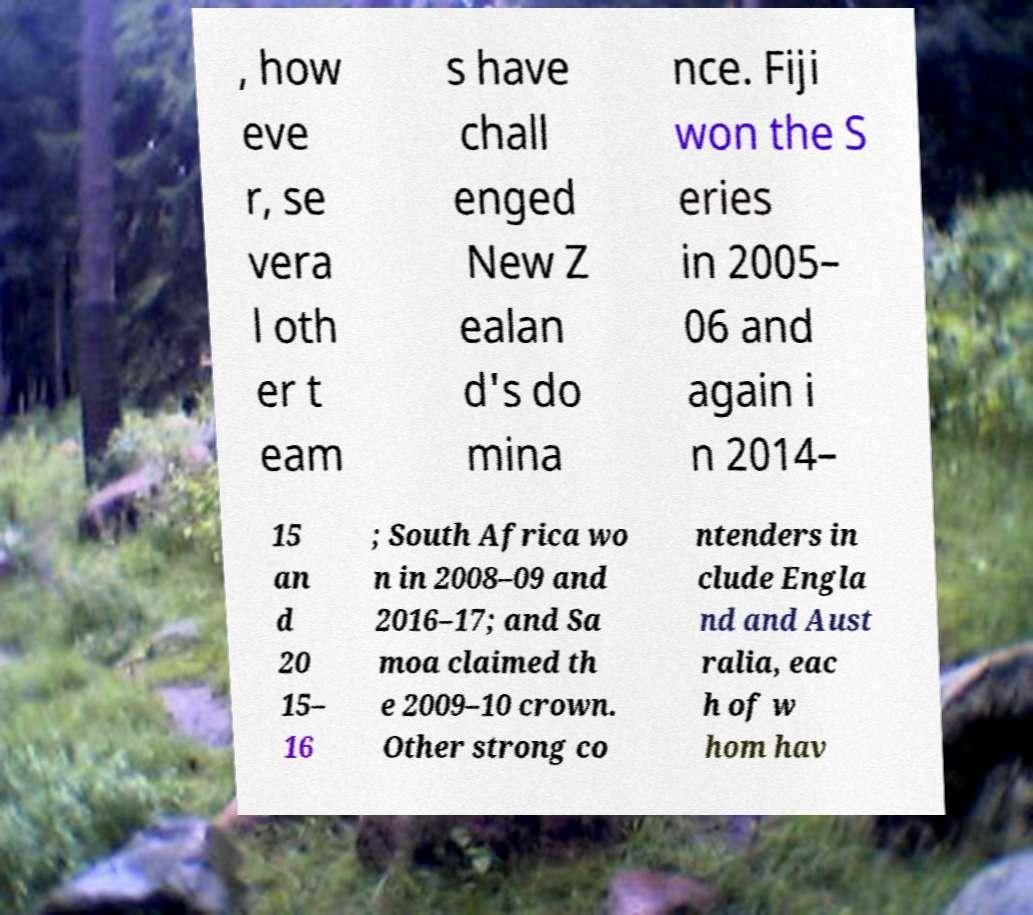I need the written content from this picture converted into text. Can you do that? , how eve r, se vera l oth er t eam s have chall enged New Z ealan d's do mina nce. Fiji won the S eries in 2005– 06 and again i n 2014– 15 an d 20 15– 16 ; South Africa wo n in 2008–09 and 2016–17; and Sa moa claimed th e 2009–10 crown. Other strong co ntenders in clude Engla nd and Aust ralia, eac h of w hom hav 